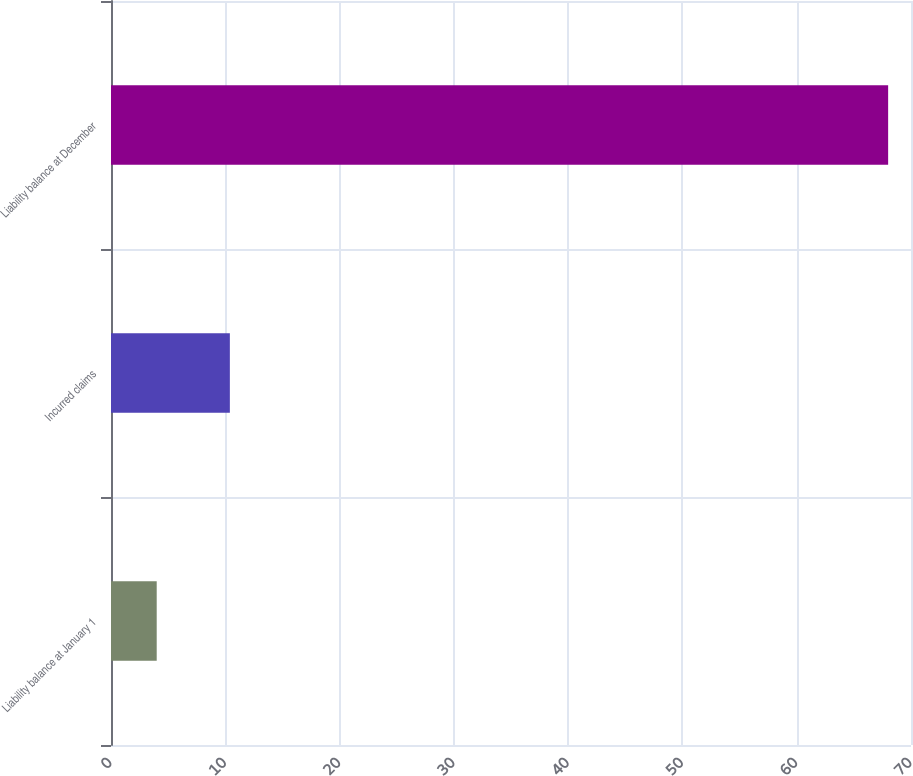Convert chart to OTSL. <chart><loc_0><loc_0><loc_500><loc_500><bar_chart><fcel>Liability balance at January 1<fcel>Incurred claims<fcel>Liability balance at December<nl><fcel>4<fcel>10.4<fcel>68<nl></chart> 